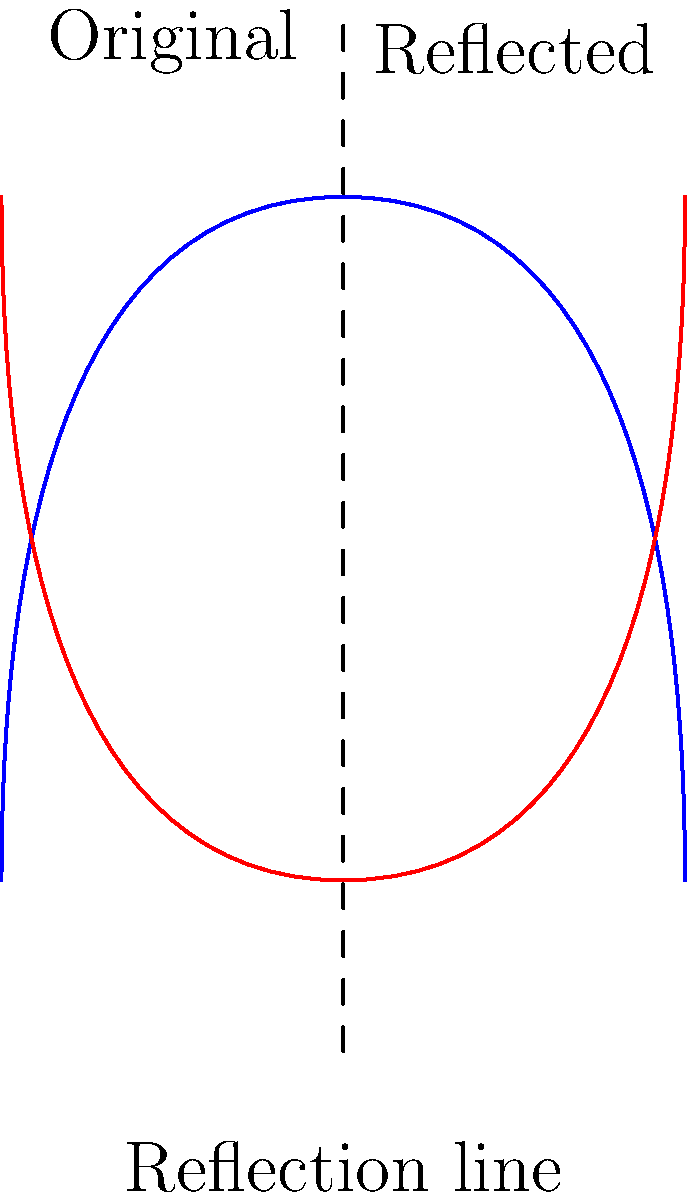In the context of gene editing and bioethics, consider the DNA double helix structure shown above. If this structure is reflected across the vertical dashed line, what ethical implications might arise from the mirroring of genetic information? How does this reflection relate to the concept of gene duplication and its potential consequences in genetic engineering? To answer this question, we need to consider several aspects of gene editing, bioethics, and the implications of genetic mirroring:

1. Geometric interpretation: The reflection of the DNA double helix across the vertical line represents a perfect mirroring of the genetic information. This is analogous to gene duplication in nature.

2. Gene duplication: In biology, gene duplication is a process where a region of DNA containing a gene is duplicated. This can occur naturally or through artificial means in genetic engineering.

3. Potential benefits:
   a. Increased genetic diversity
   b. Evolution of new gene functions
   c. Potential for enhancing desired traits

4. Ethical concerns:
   a. Unintended consequences of artificial gene duplication
   b. Potential for creating genetic imbalances
   c. Risk of introducing harmful mutations
   d. Questions about the limits of human intervention in genetics

5. Bioethical considerations:
   a. The principle of non-maleficence (do no harm)
   b. Respect for human dignity and genetic integrity
   c. Equitable access to genetic technologies
   d. Long-term effects on human evolution and biodiversity

6. Responsible gene editing:
   a. Need for strict regulations and oversight
   b. Importance of transparency in research and applications
   c. Consideration of societal impact and public opinion

The reflection in the diagram serves as a visual metaphor for the ethical dilemma of artificially replicating or modifying genetic information. It highlights the need for careful consideration of the potential consequences and the importance of responsible approaches to gene editing.
Answer: The reflection illustrates potential ethical issues in gene duplication, including unintended consequences, genetic imbalances, and the need for responsible gene editing practices that consider long-term effects on human evolution and biodiversity. 